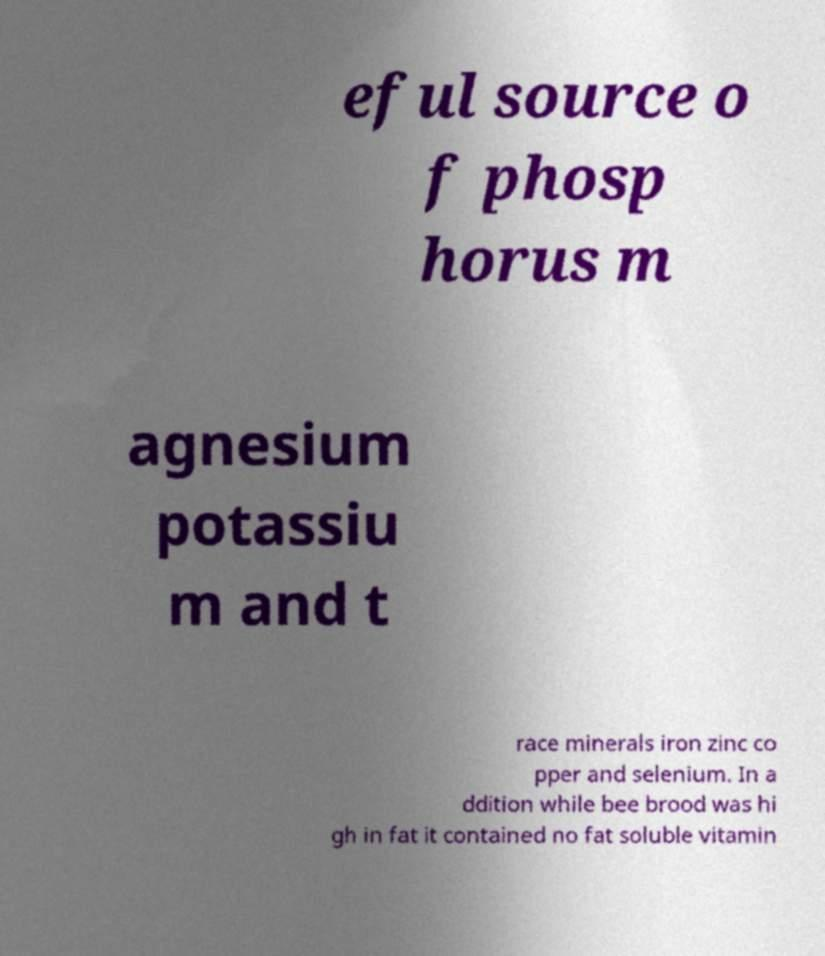Could you extract and type out the text from this image? eful source o f phosp horus m agnesium potassiu m and t race minerals iron zinc co pper and selenium. In a ddition while bee brood was hi gh in fat it contained no fat soluble vitamin 